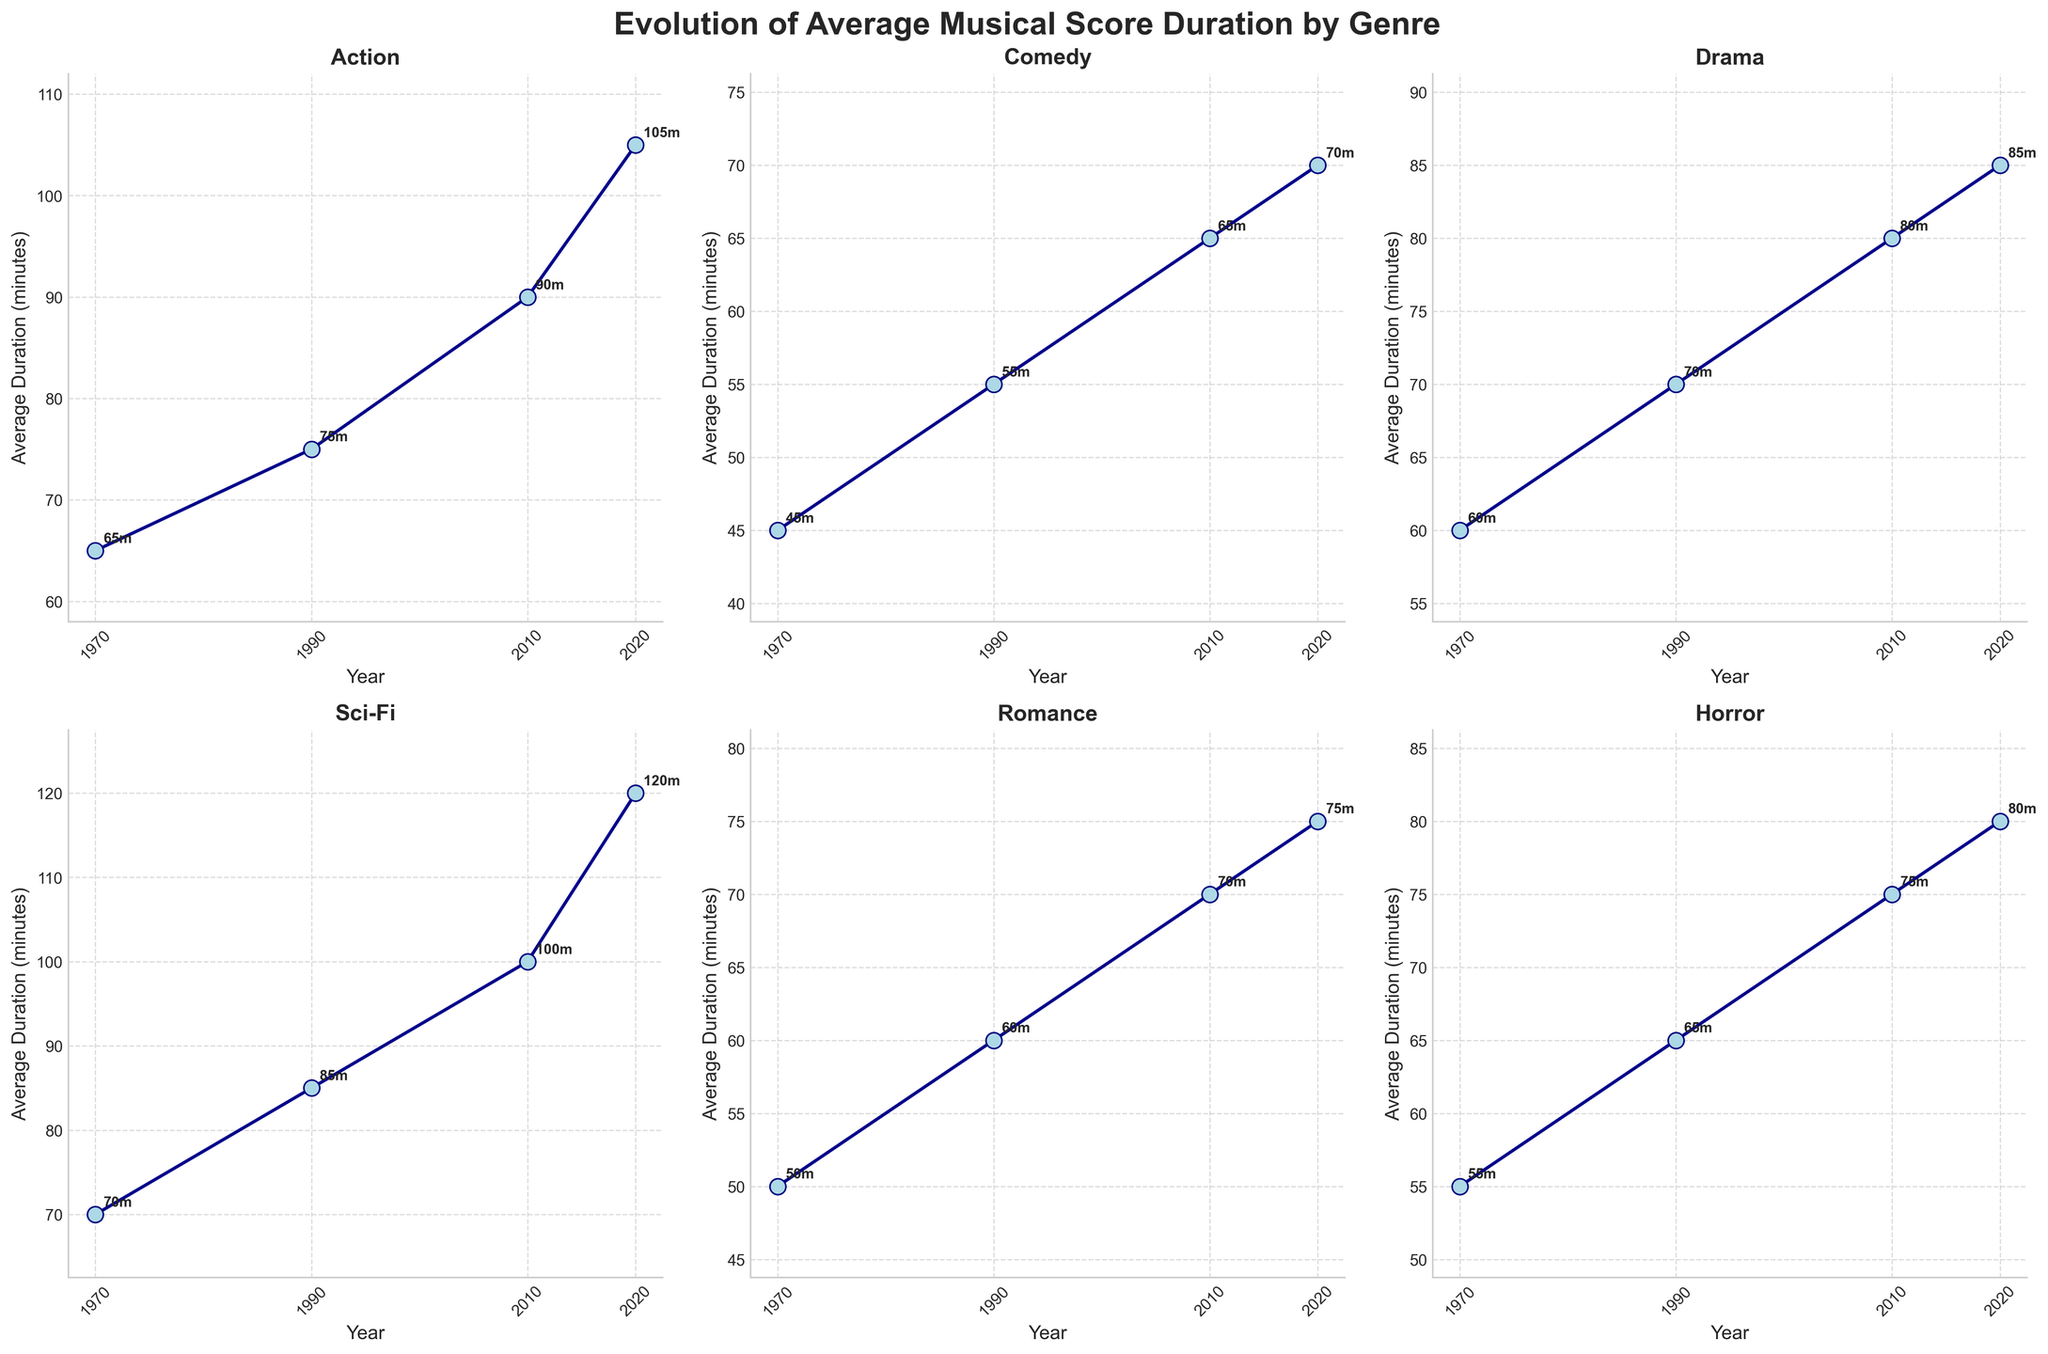What's the title of the figure? The title is at the top center of the figure, and it reads "Evolution of Average Musical Score Duration by Genre".
Answer: Evolution of Average Musical Score Duration by Genre Which genre has the longest average musical score duration in 2020? By looking at the 2020 tick on the x-axis and comparing the y-values for all genres, Sci-Fi has the longest average musical score duration in 2020.
Answer: Sci-Fi How many genres have data points in the figure? Each subplot has a title with the genre name, and there are a total of six subplots.
Answer: 6 What is the average musical score duration of Comedy in 2010? Find the Comedy subplot and identify the y-value corresponding to 2010 on the x-axis. The annotation shows 65 minutes.
Answer: 65 minutes By how many minutes did the average musical score duration for Action increase from 1970 to 2020? Subtract the y-value for 1970 (65 minutes) from the y-value for 2020 (105 minutes). The increase is 105 - 65 = 40 minutes.
Answer: 40 minutes Which genre shows the smallest change in average musical score duration from 1970 to 2020? Compare the differences in y-values for each genre between 1970 and 2020. Romance changed from 50 to 75 minutes, a difference of 25 minutes, which is the smallest.
Answer: Romance What distinctive pattern can be observed in the Sci-Fi subplot? Sci-Fi shows a consistently steep increase in average musical score duration, most notably between 2010 and 2020.
Answer: Steep increase Do any genres show a plateau or only slight change at any point? The Comedy genre shows only a slight change from 2010 (65 minutes) to 2020 (70 minutes).
Answer: Comedy What is the trend for the average musical score duration in Drama over the years? The Drama subplot indicates an upward trend with values increasing consistently from 60 minutes in 1970 to 85 minutes in 2020.
Answer: Upward trend 